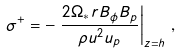Convert formula to latex. <formula><loc_0><loc_0><loc_500><loc_500>\sigma ^ { + } = - \left . \frac { 2 \Omega _ { * } r B _ { \phi } B _ { p } } { \rho u ^ { 2 } u _ { p } } \right | _ { z = h } \, ,</formula> 